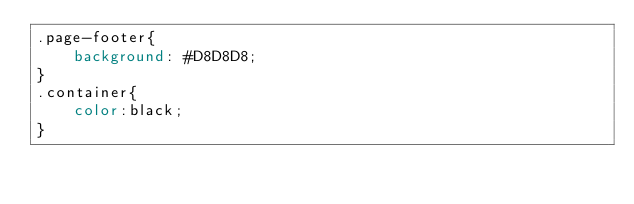Convert code to text. <code><loc_0><loc_0><loc_500><loc_500><_CSS_>.page-footer{
    background: #D8D8D8;
}
.container{
    color:black;
}</code> 